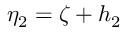Convert formula to latex. <formula><loc_0><loc_0><loc_500><loc_500>\eta _ { 2 } = \zeta + h _ { 2 }</formula> 